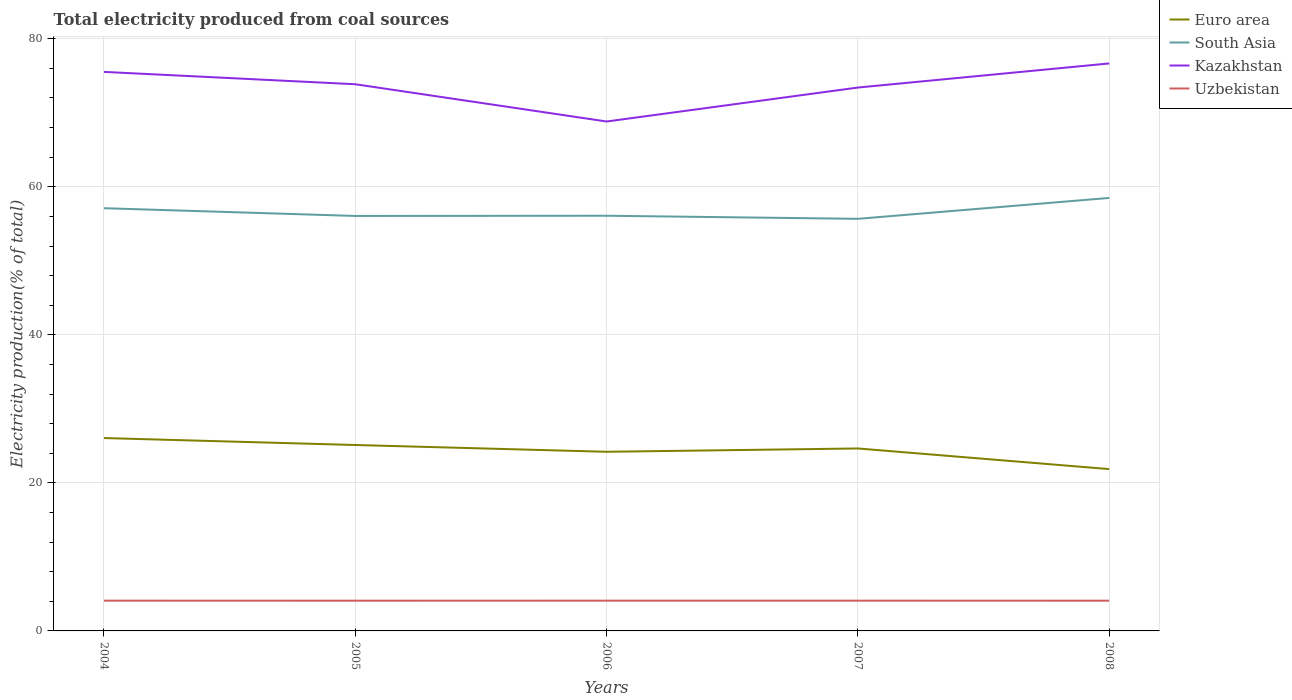Does the line corresponding to Kazakhstan intersect with the line corresponding to Euro area?
Keep it short and to the point. No. Is the number of lines equal to the number of legend labels?
Ensure brevity in your answer.  Yes. Across all years, what is the maximum total electricity produced in Euro area?
Ensure brevity in your answer.  21.86. What is the total total electricity produced in Uzbekistan in the graph?
Ensure brevity in your answer.  0. What is the difference between the highest and the second highest total electricity produced in Uzbekistan?
Offer a very short reply. 0. Is the total electricity produced in Euro area strictly greater than the total electricity produced in Kazakhstan over the years?
Offer a terse response. Yes. How many years are there in the graph?
Your response must be concise. 5. What is the difference between two consecutive major ticks on the Y-axis?
Provide a short and direct response. 20. Does the graph contain grids?
Make the answer very short. Yes. Where does the legend appear in the graph?
Your answer should be compact. Top right. What is the title of the graph?
Your answer should be compact. Total electricity produced from coal sources. What is the label or title of the X-axis?
Your response must be concise. Years. What is the Electricity production(% of total) in Euro area in 2004?
Your answer should be compact. 26.06. What is the Electricity production(% of total) in South Asia in 2004?
Your answer should be compact. 57.11. What is the Electricity production(% of total) in Kazakhstan in 2004?
Make the answer very short. 75.52. What is the Electricity production(% of total) of Uzbekistan in 2004?
Provide a succinct answer. 4.09. What is the Electricity production(% of total) of Euro area in 2005?
Your answer should be compact. 25.12. What is the Electricity production(% of total) in South Asia in 2005?
Offer a terse response. 56.06. What is the Electricity production(% of total) of Kazakhstan in 2005?
Keep it short and to the point. 73.85. What is the Electricity production(% of total) of Uzbekistan in 2005?
Ensure brevity in your answer.  4.08. What is the Electricity production(% of total) in Euro area in 2006?
Make the answer very short. 24.2. What is the Electricity production(% of total) of South Asia in 2006?
Offer a terse response. 56.09. What is the Electricity production(% of total) of Kazakhstan in 2006?
Provide a short and direct response. 68.82. What is the Electricity production(% of total) in Uzbekistan in 2006?
Your response must be concise. 4.09. What is the Electricity production(% of total) of Euro area in 2007?
Your answer should be very brief. 24.65. What is the Electricity production(% of total) in South Asia in 2007?
Make the answer very short. 55.67. What is the Electricity production(% of total) in Kazakhstan in 2007?
Provide a short and direct response. 73.41. What is the Electricity production(% of total) in Uzbekistan in 2007?
Your answer should be very brief. 4.09. What is the Electricity production(% of total) in Euro area in 2008?
Give a very brief answer. 21.86. What is the Electricity production(% of total) in South Asia in 2008?
Ensure brevity in your answer.  58.49. What is the Electricity production(% of total) in Kazakhstan in 2008?
Your response must be concise. 76.66. What is the Electricity production(% of total) in Uzbekistan in 2008?
Your answer should be very brief. 4.09. Across all years, what is the maximum Electricity production(% of total) of Euro area?
Ensure brevity in your answer.  26.06. Across all years, what is the maximum Electricity production(% of total) in South Asia?
Keep it short and to the point. 58.49. Across all years, what is the maximum Electricity production(% of total) in Kazakhstan?
Provide a short and direct response. 76.66. Across all years, what is the maximum Electricity production(% of total) in Uzbekistan?
Keep it short and to the point. 4.09. Across all years, what is the minimum Electricity production(% of total) in Euro area?
Your answer should be compact. 21.86. Across all years, what is the minimum Electricity production(% of total) of South Asia?
Offer a terse response. 55.67. Across all years, what is the minimum Electricity production(% of total) of Kazakhstan?
Offer a very short reply. 68.82. Across all years, what is the minimum Electricity production(% of total) of Uzbekistan?
Keep it short and to the point. 4.08. What is the total Electricity production(% of total) in Euro area in the graph?
Provide a succinct answer. 121.88. What is the total Electricity production(% of total) of South Asia in the graph?
Your answer should be very brief. 283.42. What is the total Electricity production(% of total) of Kazakhstan in the graph?
Keep it short and to the point. 368.26. What is the total Electricity production(% of total) of Uzbekistan in the graph?
Provide a short and direct response. 20.43. What is the difference between the Electricity production(% of total) in Euro area in 2004 and that in 2005?
Your answer should be compact. 0.94. What is the difference between the Electricity production(% of total) of South Asia in 2004 and that in 2005?
Make the answer very short. 1.05. What is the difference between the Electricity production(% of total) in Kazakhstan in 2004 and that in 2005?
Your answer should be compact. 1.67. What is the difference between the Electricity production(% of total) in Uzbekistan in 2004 and that in 2005?
Offer a terse response. 0. What is the difference between the Electricity production(% of total) in Euro area in 2004 and that in 2006?
Provide a short and direct response. 1.85. What is the difference between the Electricity production(% of total) in South Asia in 2004 and that in 2006?
Give a very brief answer. 1.02. What is the difference between the Electricity production(% of total) of Kazakhstan in 2004 and that in 2006?
Offer a very short reply. 6.7. What is the difference between the Electricity production(% of total) of Uzbekistan in 2004 and that in 2006?
Provide a succinct answer. -0. What is the difference between the Electricity production(% of total) in Euro area in 2004 and that in 2007?
Provide a short and direct response. 1.41. What is the difference between the Electricity production(% of total) of South Asia in 2004 and that in 2007?
Ensure brevity in your answer.  1.43. What is the difference between the Electricity production(% of total) of Kazakhstan in 2004 and that in 2007?
Give a very brief answer. 2.12. What is the difference between the Electricity production(% of total) in Euro area in 2004 and that in 2008?
Keep it short and to the point. 4.19. What is the difference between the Electricity production(% of total) of South Asia in 2004 and that in 2008?
Provide a succinct answer. -1.39. What is the difference between the Electricity production(% of total) of Kazakhstan in 2004 and that in 2008?
Provide a short and direct response. -1.14. What is the difference between the Electricity production(% of total) in Uzbekistan in 2004 and that in 2008?
Offer a terse response. 0. What is the difference between the Electricity production(% of total) of Euro area in 2005 and that in 2006?
Ensure brevity in your answer.  0.92. What is the difference between the Electricity production(% of total) of South Asia in 2005 and that in 2006?
Provide a short and direct response. -0.03. What is the difference between the Electricity production(% of total) of Kazakhstan in 2005 and that in 2006?
Your answer should be very brief. 5.03. What is the difference between the Electricity production(% of total) in Uzbekistan in 2005 and that in 2006?
Give a very brief answer. -0. What is the difference between the Electricity production(% of total) of Euro area in 2005 and that in 2007?
Ensure brevity in your answer.  0.47. What is the difference between the Electricity production(% of total) of South Asia in 2005 and that in 2007?
Your answer should be compact. 0.39. What is the difference between the Electricity production(% of total) of Kazakhstan in 2005 and that in 2007?
Provide a succinct answer. 0.45. What is the difference between the Electricity production(% of total) of Uzbekistan in 2005 and that in 2007?
Offer a terse response. -0. What is the difference between the Electricity production(% of total) in Euro area in 2005 and that in 2008?
Your answer should be very brief. 3.25. What is the difference between the Electricity production(% of total) of South Asia in 2005 and that in 2008?
Keep it short and to the point. -2.44. What is the difference between the Electricity production(% of total) in Kazakhstan in 2005 and that in 2008?
Offer a terse response. -2.81. What is the difference between the Electricity production(% of total) of Uzbekistan in 2005 and that in 2008?
Offer a terse response. -0. What is the difference between the Electricity production(% of total) in Euro area in 2006 and that in 2007?
Your answer should be very brief. -0.45. What is the difference between the Electricity production(% of total) of South Asia in 2006 and that in 2007?
Give a very brief answer. 0.42. What is the difference between the Electricity production(% of total) of Kazakhstan in 2006 and that in 2007?
Provide a succinct answer. -4.59. What is the difference between the Electricity production(% of total) of Euro area in 2006 and that in 2008?
Your answer should be compact. 2.34. What is the difference between the Electricity production(% of total) in South Asia in 2006 and that in 2008?
Your answer should be compact. -2.41. What is the difference between the Electricity production(% of total) in Kazakhstan in 2006 and that in 2008?
Your answer should be very brief. -7.84. What is the difference between the Electricity production(% of total) of Uzbekistan in 2006 and that in 2008?
Your answer should be compact. 0. What is the difference between the Electricity production(% of total) of Euro area in 2007 and that in 2008?
Give a very brief answer. 2.79. What is the difference between the Electricity production(% of total) of South Asia in 2007 and that in 2008?
Make the answer very short. -2.82. What is the difference between the Electricity production(% of total) in Kazakhstan in 2007 and that in 2008?
Keep it short and to the point. -3.26. What is the difference between the Electricity production(% of total) of Uzbekistan in 2007 and that in 2008?
Your response must be concise. 0. What is the difference between the Electricity production(% of total) of Euro area in 2004 and the Electricity production(% of total) of South Asia in 2005?
Offer a terse response. -30. What is the difference between the Electricity production(% of total) of Euro area in 2004 and the Electricity production(% of total) of Kazakhstan in 2005?
Make the answer very short. -47.8. What is the difference between the Electricity production(% of total) in Euro area in 2004 and the Electricity production(% of total) in Uzbekistan in 2005?
Offer a terse response. 21.97. What is the difference between the Electricity production(% of total) in South Asia in 2004 and the Electricity production(% of total) in Kazakhstan in 2005?
Offer a very short reply. -16.75. What is the difference between the Electricity production(% of total) of South Asia in 2004 and the Electricity production(% of total) of Uzbekistan in 2005?
Provide a short and direct response. 53.02. What is the difference between the Electricity production(% of total) in Kazakhstan in 2004 and the Electricity production(% of total) in Uzbekistan in 2005?
Provide a short and direct response. 71.44. What is the difference between the Electricity production(% of total) in Euro area in 2004 and the Electricity production(% of total) in South Asia in 2006?
Your answer should be compact. -30.03. What is the difference between the Electricity production(% of total) in Euro area in 2004 and the Electricity production(% of total) in Kazakhstan in 2006?
Offer a very short reply. -42.76. What is the difference between the Electricity production(% of total) in Euro area in 2004 and the Electricity production(% of total) in Uzbekistan in 2006?
Provide a succinct answer. 21.97. What is the difference between the Electricity production(% of total) of South Asia in 2004 and the Electricity production(% of total) of Kazakhstan in 2006?
Keep it short and to the point. -11.71. What is the difference between the Electricity production(% of total) in South Asia in 2004 and the Electricity production(% of total) in Uzbekistan in 2006?
Give a very brief answer. 53.02. What is the difference between the Electricity production(% of total) in Kazakhstan in 2004 and the Electricity production(% of total) in Uzbekistan in 2006?
Provide a short and direct response. 71.43. What is the difference between the Electricity production(% of total) in Euro area in 2004 and the Electricity production(% of total) in South Asia in 2007?
Offer a terse response. -29.62. What is the difference between the Electricity production(% of total) of Euro area in 2004 and the Electricity production(% of total) of Kazakhstan in 2007?
Your answer should be compact. -47.35. What is the difference between the Electricity production(% of total) in Euro area in 2004 and the Electricity production(% of total) in Uzbekistan in 2007?
Give a very brief answer. 21.97. What is the difference between the Electricity production(% of total) of South Asia in 2004 and the Electricity production(% of total) of Kazakhstan in 2007?
Your answer should be very brief. -16.3. What is the difference between the Electricity production(% of total) in South Asia in 2004 and the Electricity production(% of total) in Uzbekistan in 2007?
Your response must be concise. 53.02. What is the difference between the Electricity production(% of total) of Kazakhstan in 2004 and the Electricity production(% of total) of Uzbekistan in 2007?
Provide a succinct answer. 71.44. What is the difference between the Electricity production(% of total) in Euro area in 2004 and the Electricity production(% of total) in South Asia in 2008?
Make the answer very short. -32.44. What is the difference between the Electricity production(% of total) in Euro area in 2004 and the Electricity production(% of total) in Kazakhstan in 2008?
Ensure brevity in your answer.  -50.61. What is the difference between the Electricity production(% of total) of Euro area in 2004 and the Electricity production(% of total) of Uzbekistan in 2008?
Provide a short and direct response. 21.97. What is the difference between the Electricity production(% of total) in South Asia in 2004 and the Electricity production(% of total) in Kazakhstan in 2008?
Provide a short and direct response. -19.56. What is the difference between the Electricity production(% of total) of South Asia in 2004 and the Electricity production(% of total) of Uzbekistan in 2008?
Ensure brevity in your answer.  53.02. What is the difference between the Electricity production(% of total) of Kazakhstan in 2004 and the Electricity production(% of total) of Uzbekistan in 2008?
Your answer should be compact. 71.44. What is the difference between the Electricity production(% of total) of Euro area in 2005 and the Electricity production(% of total) of South Asia in 2006?
Ensure brevity in your answer.  -30.97. What is the difference between the Electricity production(% of total) in Euro area in 2005 and the Electricity production(% of total) in Kazakhstan in 2006?
Provide a succinct answer. -43.7. What is the difference between the Electricity production(% of total) of Euro area in 2005 and the Electricity production(% of total) of Uzbekistan in 2006?
Keep it short and to the point. 21.03. What is the difference between the Electricity production(% of total) of South Asia in 2005 and the Electricity production(% of total) of Kazakhstan in 2006?
Offer a terse response. -12.76. What is the difference between the Electricity production(% of total) in South Asia in 2005 and the Electricity production(% of total) in Uzbekistan in 2006?
Your answer should be very brief. 51.97. What is the difference between the Electricity production(% of total) of Kazakhstan in 2005 and the Electricity production(% of total) of Uzbekistan in 2006?
Give a very brief answer. 69.77. What is the difference between the Electricity production(% of total) in Euro area in 2005 and the Electricity production(% of total) in South Asia in 2007?
Ensure brevity in your answer.  -30.55. What is the difference between the Electricity production(% of total) of Euro area in 2005 and the Electricity production(% of total) of Kazakhstan in 2007?
Offer a very short reply. -48.29. What is the difference between the Electricity production(% of total) of Euro area in 2005 and the Electricity production(% of total) of Uzbekistan in 2007?
Offer a very short reply. 21.03. What is the difference between the Electricity production(% of total) in South Asia in 2005 and the Electricity production(% of total) in Kazakhstan in 2007?
Your answer should be compact. -17.35. What is the difference between the Electricity production(% of total) of South Asia in 2005 and the Electricity production(% of total) of Uzbekistan in 2007?
Keep it short and to the point. 51.97. What is the difference between the Electricity production(% of total) of Kazakhstan in 2005 and the Electricity production(% of total) of Uzbekistan in 2007?
Ensure brevity in your answer.  69.77. What is the difference between the Electricity production(% of total) of Euro area in 2005 and the Electricity production(% of total) of South Asia in 2008?
Your response must be concise. -33.38. What is the difference between the Electricity production(% of total) of Euro area in 2005 and the Electricity production(% of total) of Kazakhstan in 2008?
Provide a succinct answer. -51.55. What is the difference between the Electricity production(% of total) in Euro area in 2005 and the Electricity production(% of total) in Uzbekistan in 2008?
Make the answer very short. 21.03. What is the difference between the Electricity production(% of total) in South Asia in 2005 and the Electricity production(% of total) in Kazakhstan in 2008?
Keep it short and to the point. -20.6. What is the difference between the Electricity production(% of total) in South Asia in 2005 and the Electricity production(% of total) in Uzbekistan in 2008?
Keep it short and to the point. 51.97. What is the difference between the Electricity production(% of total) in Kazakhstan in 2005 and the Electricity production(% of total) in Uzbekistan in 2008?
Offer a terse response. 69.77. What is the difference between the Electricity production(% of total) in Euro area in 2006 and the Electricity production(% of total) in South Asia in 2007?
Offer a terse response. -31.47. What is the difference between the Electricity production(% of total) of Euro area in 2006 and the Electricity production(% of total) of Kazakhstan in 2007?
Provide a short and direct response. -49.21. What is the difference between the Electricity production(% of total) of Euro area in 2006 and the Electricity production(% of total) of Uzbekistan in 2007?
Your response must be concise. 20.12. What is the difference between the Electricity production(% of total) in South Asia in 2006 and the Electricity production(% of total) in Kazakhstan in 2007?
Your answer should be compact. -17.32. What is the difference between the Electricity production(% of total) in South Asia in 2006 and the Electricity production(% of total) in Uzbekistan in 2007?
Ensure brevity in your answer.  52. What is the difference between the Electricity production(% of total) in Kazakhstan in 2006 and the Electricity production(% of total) in Uzbekistan in 2007?
Offer a terse response. 64.73. What is the difference between the Electricity production(% of total) in Euro area in 2006 and the Electricity production(% of total) in South Asia in 2008?
Give a very brief answer. -34.29. What is the difference between the Electricity production(% of total) of Euro area in 2006 and the Electricity production(% of total) of Kazakhstan in 2008?
Ensure brevity in your answer.  -52.46. What is the difference between the Electricity production(% of total) in Euro area in 2006 and the Electricity production(% of total) in Uzbekistan in 2008?
Your response must be concise. 20.12. What is the difference between the Electricity production(% of total) in South Asia in 2006 and the Electricity production(% of total) in Kazakhstan in 2008?
Provide a short and direct response. -20.57. What is the difference between the Electricity production(% of total) in South Asia in 2006 and the Electricity production(% of total) in Uzbekistan in 2008?
Ensure brevity in your answer.  52. What is the difference between the Electricity production(% of total) of Kazakhstan in 2006 and the Electricity production(% of total) of Uzbekistan in 2008?
Give a very brief answer. 64.73. What is the difference between the Electricity production(% of total) in Euro area in 2007 and the Electricity production(% of total) in South Asia in 2008?
Keep it short and to the point. -33.85. What is the difference between the Electricity production(% of total) of Euro area in 2007 and the Electricity production(% of total) of Kazakhstan in 2008?
Provide a succinct answer. -52.02. What is the difference between the Electricity production(% of total) of Euro area in 2007 and the Electricity production(% of total) of Uzbekistan in 2008?
Ensure brevity in your answer.  20.56. What is the difference between the Electricity production(% of total) of South Asia in 2007 and the Electricity production(% of total) of Kazakhstan in 2008?
Your answer should be compact. -20.99. What is the difference between the Electricity production(% of total) in South Asia in 2007 and the Electricity production(% of total) in Uzbekistan in 2008?
Give a very brief answer. 51.59. What is the difference between the Electricity production(% of total) of Kazakhstan in 2007 and the Electricity production(% of total) of Uzbekistan in 2008?
Provide a succinct answer. 69.32. What is the average Electricity production(% of total) in Euro area per year?
Give a very brief answer. 24.38. What is the average Electricity production(% of total) of South Asia per year?
Make the answer very short. 56.68. What is the average Electricity production(% of total) in Kazakhstan per year?
Your answer should be compact. 73.65. What is the average Electricity production(% of total) in Uzbekistan per year?
Your answer should be compact. 4.09. In the year 2004, what is the difference between the Electricity production(% of total) of Euro area and Electricity production(% of total) of South Asia?
Your answer should be compact. -31.05. In the year 2004, what is the difference between the Electricity production(% of total) of Euro area and Electricity production(% of total) of Kazakhstan?
Offer a terse response. -49.47. In the year 2004, what is the difference between the Electricity production(% of total) in Euro area and Electricity production(% of total) in Uzbekistan?
Offer a very short reply. 21.97. In the year 2004, what is the difference between the Electricity production(% of total) of South Asia and Electricity production(% of total) of Kazakhstan?
Ensure brevity in your answer.  -18.42. In the year 2004, what is the difference between the Electricity production(% of total) in South Asia and Electricity production(% of total) in Uzbekistan?
Ensure brevity in your answer.  53.02. In the year 2004, what is the difference between the Electricity production(% of total) of Kazakhstan and Electricity production(% of total) of Uzbekistan?
Keep it short and to the point. 71.44. In the year 2005, what is the difference between the Electricity production(% of total) of Euro area and Electricity production(% of total) of South Asia?
Your answer should be compact. -30.94. In the year 2005, what is the difference between the Electricity production(% of total) in Euro area and Electricity production(% of total) in Kazakhstan?
Offer a terse response. -48.74. In the year 2005, what is the difference between the Electricity production(% of total) in Euro area and Electricity production(% of total) in Uzbekistan?
Your answer should be compact. 21.03. In the year 2005, what is the difference between the Electricity production(% of total) in South Asia and Electricity production(% of total) in Kazakhstan?
Keep it short and to the point. -17.79. In the year 2005, what is the difference between the Electricity production(% of total) in South Asia and Electricity production(% of total) in Uzbekistan?
Your response must be concise. 51.98. In the year 2005, what is the difference between the Electricity production(% of total) in Kazakhstan and Electricity production(% of total) in Uzbekistan?
Keep it short and to the point. 69.77. In the year 2006, what is the difference between the Electricity production(% of total) of Euro area and Electricity production(% of total) of South Asia?
Offer a terse response. -31.89. In the year 2006, what is the difference between the Electricity production(% of total) in Euro area and Electricity production(% of total) in Kazakhstan?
Your answer should be very brief. -44.62. In the year 2006, what is the difference between the Electricity production(% of total) in Euro area and Electricity production(% of total) in Uzbekistan?
Give a very brief answer. 20.11. In the year 2006, what is the difference between the Electricity production(% of total) in South Asia and Electricity production(% of total) in Kazakhstan?
Offer a very short reply. -12.73. In the year 2006, what is the difference between the Electricity production(% of total) in South Asia and Electricity production(% of total) in Uzbekistan?
Provide a succinct answer. 52. In the year 2006, what is the difference between the Electricity production(% of total) of Kazakhstan and Electricity production(% of total) of Uzbekistan?
Offer a terse response. 64.73. In the year 2007, what is the difference between the Electricity production(% of total) in Euro area and Electricity production(% of total) in South Asia?
Make the answer very short. -31.02. In the year 2007, what is the difference between the Electricity production(% of total) of Euro area and Electricity production(% of total) of Kazakhstan?
Your answer should be very brief. -48.76. In the year 2007, what is the difference between the Electricity production(% of total) in Euro area and Electricity production(% of total) in Uzbekistan?
Give a very brief answer. 20.56. In the year 2007, what is the difference between the Electricity production(% of total) of South Asia and Electricity production(% of total) of Kazakhstan?
Provide a short and direct response. -17.74. In the year 2007, what is the difference between the Electricity production(% of total) of South Asia and Electricity production(% of total) of Uzbekistan?
Your answer should be very brief. 51.59. In the year 2007, what is the difference between the Electricity production(% of total) of Kazakhstan and Electricity production(% of total) of Uzbekistan?
Your response must be concise. 69.32. In the year 2008, what is the difference between the Electricity production(% of total) of Euro area and Electricity production(% of total) of South Asia?
Offer a terse response. -36.63. In the year 2008, what is the difference between the Electricity production(% of total) in Euro area and Electricity production(% of total) in Kazakhstan?
Give a very brief answer. -54.8. In the year 2008, what is the difference between the Electricity production(% of total) of Euro area and Electricity production(% of total) of Uzbekistan?
Provide a short and direct response. 17.78. In the year 2008, what is the difference between the Electricity production(% of total) in South Asia and Electricity production(% of total) in Kazakhstan?
Give a very brief answer. -18.17. In the year 2008, what is the difference between the Electricity production(% of total) of South Asia and Electricity production(% of total) of Uzbekistan?
Give a very brief answer. 54.41. In the year 2008, what is the difference between the Electricity production(% of total) of Kazakhstan and Electricity production(% of total) of Uzbekistan?
Offer a terse response. 72.58. What is the ratio of the Electricity production(% of total) of Euro area in 2004 to that in 2005?
Your answer should be compact. 1.04. What is the ratio of the Electricity production(% of total) of South Asia in 2004 to that in 2005?
Make the answer very short. 1.02. What is the ratio of the Electricity production(% of total) of Kazakhstan in 2004 to that in 2005?
Give a very brief answer. 1.02. What is the ratio of the Electricity production(% of total) in Euro area in 2004 to that in 2006?
Give a very brief answer. 1.08. What is the ratio of the Electricity production(% of total) of South Asia in 2004 to that in 2006?
Ensure brevity in your answer.  1.02. What is the ratio of the Electricity production(% of total) of Kazakhstan in 2004 to that in 2006?
Your answer should be compact. 1.1. What is the ratio of the Electricity production(% of total) in Uzbekistan in 2004 to that in 2006?
Offer a very short reply. 1. What is the ratio of the Electricity production(% of total) of Euro area in 2004 to that in 2007?
Offer a very short reply. 1.06. What is the ratio of the Electricity production(% of total) in South Asia in 2004 to that in 2007?
Your answer should be compact. 1.03. What is the ratio of the Electricity production(% of total) of Kazakhstan in 2004 to that in 2007?
Provide a short and direct response. 1.03. What is the ratio of the Electricity production(% of total) in Euro area in 2004 to that in 2008?
Make the answer very short. 1.19. What is the ratio of the Electricity production(% of total) of South Asia in 2004 to that in 2008?
Keep it short and to the point. 0.98. What is the ratio of the Electricity production(% of total) of Kazakhstan in 2004 to that in 2008?
Give a very brief answer. 0.99. What is the ratio of the Electricity production(% of total) in Uzbekistan in 2004 to that in 2008?
Your answer should be very brief. 1. What is the ratio of the Electricity production(% of total) of Euro area in 2005 to that in 2006?
Your answer should be compact. 1.04. What is the ratio of the Electricity production(% of total) in Kazakhstan in 2005 to that in 2006?
Offer a very short reply. 1.07. What is the ratio of the Electricity production(% of total) of Uzbekistan in 2005 to that in 2006?
Provide a succinct answer. 1. What is the ratio of the Electricity production(% of total) in Euro area in 2005 to that in 2007?
Offer a terse response. 1.02. What is the ratio of the Electricity production(% of total) of South Asia in 2005 to that in 2007?
Offer a terse response. 1.01. What is the ratio of the Electricity production(% of total) in Kazakhstan in 2005 to that in 2007?
Offer a terse response. 1.01. What is the ratio of the Electricity production(% of total) of Uzbekistan in 2005 to that in 2007?
Make the answer very short. 1. What is the ratio of the Electricity production(% of total) of Euro area in 2005 to that in 2008?
Offer a very short reply. 1.15. What is the ratio of the Electricity production(% of total) in South Asia in 2005 to that in 2008?
Provide a short and direct response. 0.96. What is the ratio of the Electricity production(% of total) of Kazakhstan in 2005 to that in 2008?
Ensure brevity in your answer.  0.96. What is the ratio of the Electricity production(% of total) in Uzbekistan in 2005 to that in 2008?
Your response must be concise. 1. What is the ratio of the Electricity production(% of total) in Euro area in 2006 to that in 2007?
Offer a very short reply. 0.98. What is the ratio of the Electricity production(% of total) of South Asia in 2006 to that in 2007?
Provide a succinct answer. 1.01. What is the ratio of the Electricity production(% of total) in Uzbekistan in 2006 to that in 2007?
Keep it short and to the point. 1. What is the ratio of the Electricity production(% of total) in Euro area in 2006 to that in 2008?
Provide a short and direct response. 1.11. What is the ratio of the Electricity production(% of total) of South Asia in 2006 to that in 2008?
Keep it short and to the point. 0.96. What is the ratio of the Electricity production(% of total) in Kazakhstan in 2006 to that in 2008?
Make the answer very short. 0.9. What is the ratio of the Electricity production(% of total) in Euro area in 2007 to that in 2008?
Your response must be concise. 1.13. What is the ratio of the Electricity production(% of total) of South Asia in 2007 to that in 2008?
Offer a very short reply. 0.95. What is the ratio of the Electricity production(% of total) in Kazakhstan in 2007 to that in 2008?
Your answer should be very brief. 0.96. What is the ratio of the Electricity production(% of total) of Uzbekistan in 2007 to that in 2008?
Offer a terse response. 1. What is the difference between the highest and the second highest Electricity production(% of total) of Euro area?
Keep it short and to the point. 0.94. What is the difference between the highest and the second highest Electricity production(% of total) in South Asia?
Make the answer very short. 1.39. What is the difference between the highest and the second highest Electricity production(% of total) of Kazakhstan?
Provide a succinct answer. 1.14. What is the difference between the highest and the second highest Electricity production(% of total) in Uzbekistan?
Ensure brevity in your answer.  0. What is the difference between the highest and the lowest Electricity production(% of total) of Euro area?
Your answer should be compact. 4.19. What is the difference between the highest and the lowest Electricity production(% of total) in South Asia?
Your answer should be compact. 2.82. What is the difference between the highest and the lowest Electricity production(% of total) in Kazakhstan?
Your answer should be very brief. 7.84. What is the difference between the highest and the lowest Electricity production(% of total) in Uzbekistan?
Provide a succinct answer. 0. 